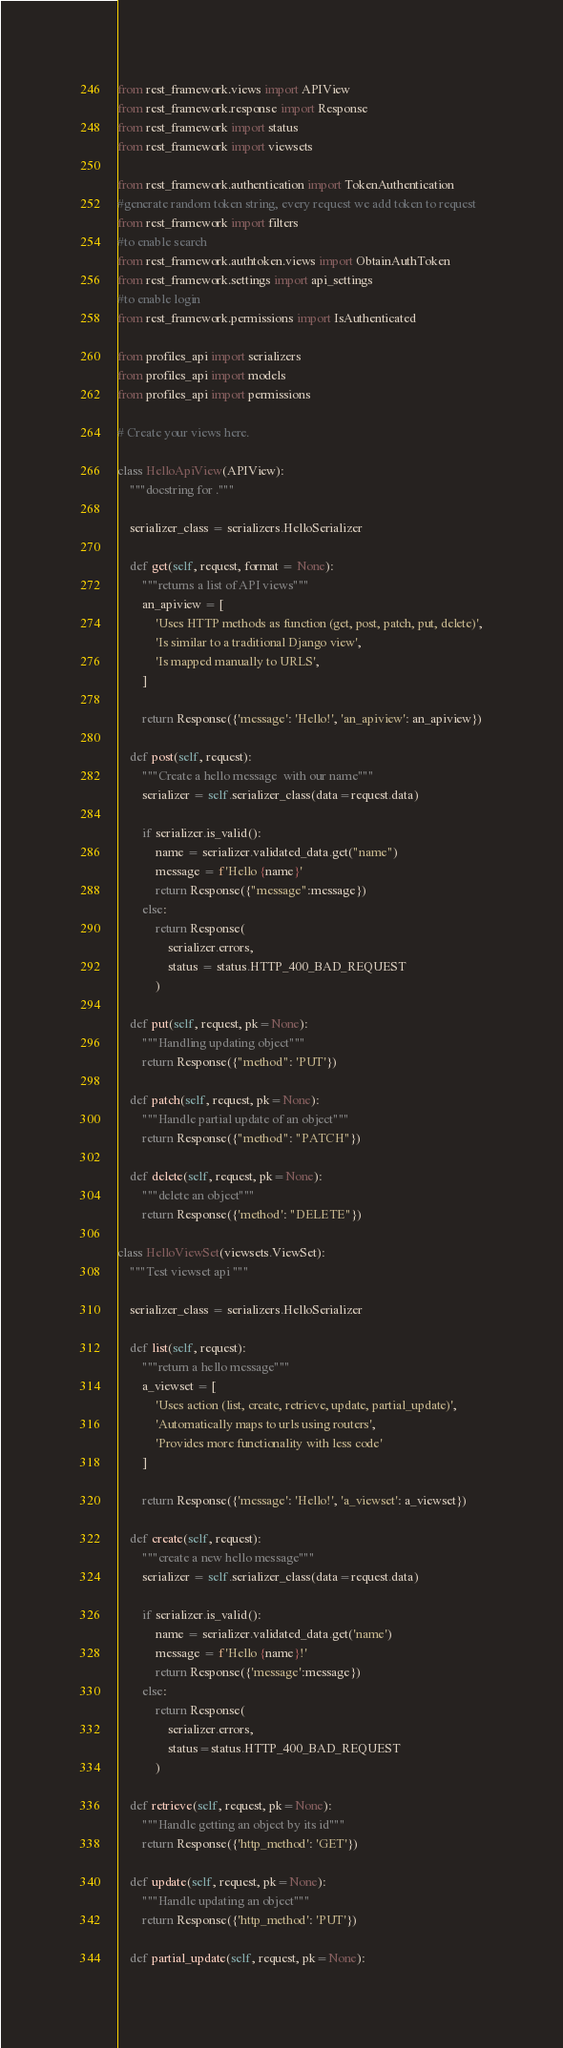<code> <loc_0><loc_0><loc_500><loc_500><_Python_>from rest_framework.views import APIView
from rest_framework.response import Response
from rest_framework import status
from rest_framework import viewsets

from rest_framework.authentication import TokenAuthentication
#generate random token string, every request we add token to request
from rest_framework import filters
#to enable search
from rest_framework.authtoken.views import ObtainAuthToken
from rest_framework.settings import api_settings
#to enable login
from rest_framework.permissions import IsAuthenticated

from profiles_api import serializers
from profiles_api import models
from profiles_api import permissions

# Create your views here.

class HelloApiView(APIView):
    """docstring for ."""

    serializer_class = serializers.HelloSerializer

    def get(self, request, format = None):
        """returns a list of API views"""
        an_apiview = [
            'Uses HTTP methods as function (get, post, patch, put, delete)',
            'Is similar to a traditional Django view',
            'Is mapped manually to URLS',
        ]

        return Response({'message': 'Hello!', 'an_apiview': an_apiview})

    def post(self, request):
        """Create a hello message  with our name"""
        serializer = self.serializer_class(data=request.data)

        if serializer.is_valid():
            name = serializer.validated_data.get("name")
            message = f'Hello {name}'
            return Response({"message":message})
        else:
            return Response(
                serializer.errors,
                status = status.HTTP_400_BAD_REQUEST
            )

    def put(self, request, pk=None):
        """Handling updating object"""
        return Response({"method": 'PUT'})

    def patch(self, request, pk=None):
        """Handle partial update of an object"""
        return Response({"method": "PATCH"})

    def delete(self, request, pk=None):
        """delete an object"""
        return Response({'method': "DELETE"})

class HelloViewSet(viewsets.ViewSet):
    """Test viewset api """

    serializer_class = serializers.HelloSerializer

    def list(self, request):
        """return a hello message"""
        a_viewset = [
            'Uses action (list, create, retrieve, update, partial_update)',
            'Automatically maps to urls using routers',
            'Provides more functionality with less code'
        ]

        return Response({'message': 'Hello!', 'a_viewset': a_viewset})

    def create(self, request):
        """create a new hello message"""
        serializer = self.serializer_class(data=request.data)

        if serializer.is_valid():
            name = serializer.validated_data.get('name')
            message = f'Hello {name}!'
            return Response({'message':message})
        else:
            return Response(
                serializer.errors,
                status=status.HTTP_400_BAD_REQUEST
            )

    def retrieve(self, request, pk=None):
        """Handle getting an object by its id"""
        return Response({'http_method': 'GET'})

    def update(self, request, pk=None):
        """Handle updating an object"""
        return Response({'http_method': 'PUT'})

    def partial_update(self, request, pk=None):</code> 